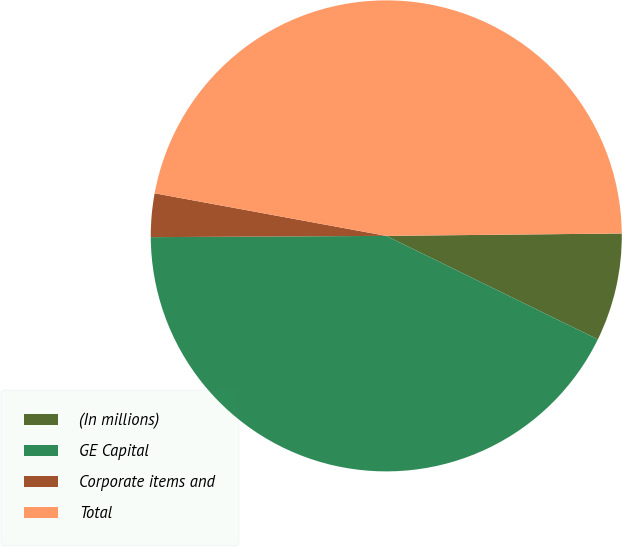<chart> <loc_0><loc_0><loc_500><loc_500><pie_chart><fcel>(In millions)<fcel>GE Capital<fcel>Corporate items and<fcel>Total<nl><fcel>7.4%<fcel>42.67%<fcel>2.98%<fcel>46.94%<nl></chart> 